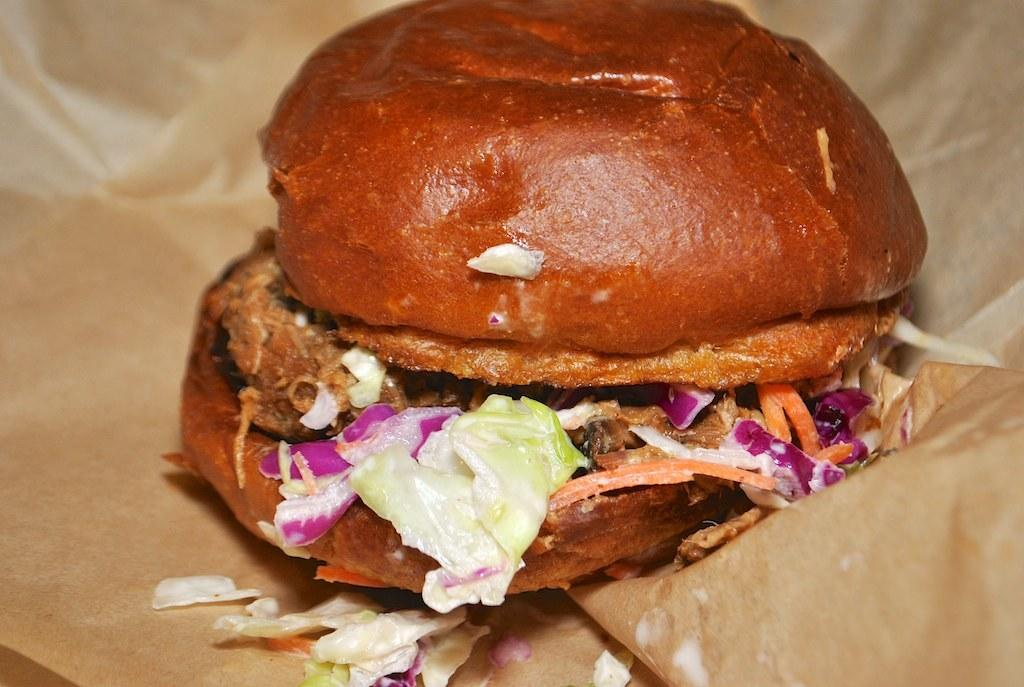What type of food can be seen in the image? There is bread in the image. What else is present in the image besides the bread? There are ingredients on the paper in the image. How many wax figures are present in the image? There are no wax figures present in the image; it features bread and ingredients on paper. What type of babies can be seen in the image? There are no babies present in the image. 